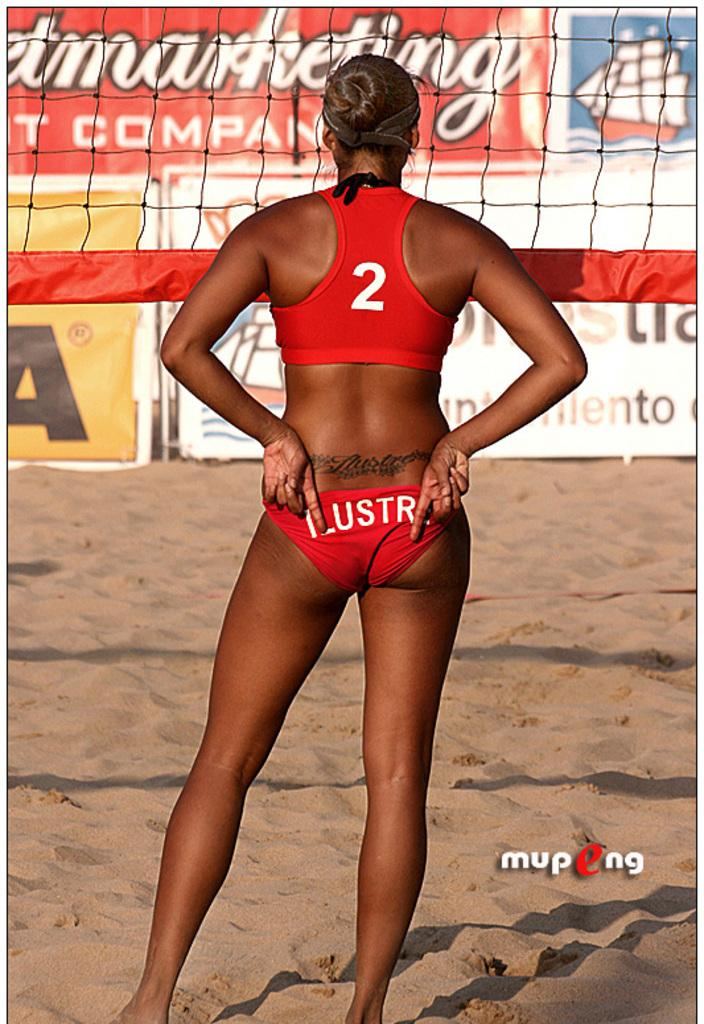<image>
Create a compact narrative representing the image presented. A woman volleyball player has the number 2 on her red top. 